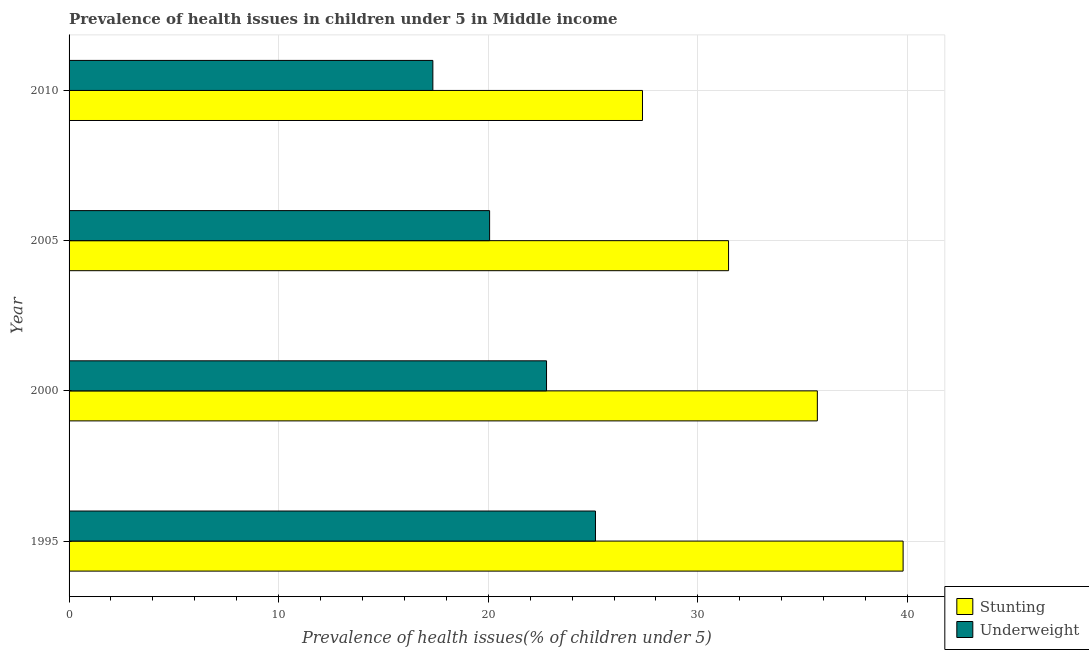How many different coloured bars are there?
Provide a succinct answer. 2. Are the number of bars on each tick of the Y-axis equal?
Your answer should be compact. Yes. What is the percentage of stunted children in 2005?
Your response must be concise. 31.46. Across all years, what is the maximum percentage of underweight children?
Ensure brevity in your answer.  25.11. Across all years, what is the minimum percentage of underweight children?
Provide a short and direct response. 17.36. In which year was the percentage of underweight children minimum?
Ensure brevity in your answer.  2010. What is the total percentage of stunted children in the graph?
Ensure brevity in your answer.  134.31. What is the difference between the percentage of underweight children in 2000 and that in 2005?
Ensure brevity in your answer.  2.72. What is the difference between the percentage of underweight children in 1995 and the percentage of stunted children in 2010?
Offer a very short reply. -2.24. What is the average percentage of stunted children per year?
Provide a succinct answer. 33.58. In the year 2010, what is the difference between the percentage of stunted children and percentage of underweight children?
Offer a terse response. 10. What is the ratio of the percentage of stunted children in 1995 to that in 2000?
Offer a very short reply. 1.11. Is the percentage of underweight children in 2005 less than that in 2010?
Provide a short and direct response. No. Is the difference between the percentage of stunted children in 1995 and 2005 greater than the difference between the percentage of underweight children in 1995 and 2005?
Keep it short and to the point. Yes. What is the difference between the highest and the second highest percentage of stunted children?
Your answer should be compact. 4.09. What is the difference between the highest and the lowest percentage of underweight children?
Your response must be concise. 7.76. Is the sum of the percentage of underweight children in 1995 and 2005 greater than the maximum percentage of stunted children across all years?
Provide a succinct answer. Yes. What does the 1st bar from the top in 1995 represents?
Provide a succinct answer. Underweight. What does the 1st bar from the bottom in 2000 represents?
Keep it short and to the point. Stunting. How many bars are there?
Provide a succinct answer. 8. Are all the bars in the graph horizontal?
Provide a short and direct response. Yes. How many years are there in the graph?
Provide a short and direct response. 4. What is the difference between two consecutive major ticks on the X-axis?
Your response must be concise. 10. Are the values on the major ticks of X-axis written in scientific E-notation?
Your answer should be very brief. No. Does the graph contain any zero values?
Make the answer very short. No. Does the graph contain grids?
Offer a very short reply. Yes. What is the title of the graph?
Offer a terse response. Prevalence of health issues in children under 5 in Middle income. What is the label or title of the X-axis?
Provide a short and direct response. Prevalence of health issues(% of children under 5). What is the Prevalence of health issues(% of children under 5) of Stunting in 1995?
Give a very brief answer. 39.79. What is the Prevalence of health issues(% of children under 5) of Underweight in 1995?
Keep it short and to the point. 25.11. What is the Prevalence of health issues(% of children under 5) in Stunting in 2000?
Your response must be concise. 35.7. What is the Prevalence of health issues(% of children under 5) of Underweight in 2000?
Your answer should be very brief. 22.78. What is the Prevalence of health issues(% of children under 5) in Stunting in 2005?
Make the answer very short. 31.46. What is the Prevalence of health issues(% of children under 5) of Underweight in 2005?
Provide a short and direct response. 20.06. What is the Prevalence of health issues(% of children under 5) in Stunting in 2010?
Give a very brief answer. 27.36. What is the Prevalence of health issues(% of children under 5) in Underweight in 2010?
Offer a terse response. 17.36. Across all years, what is the maximum Prevalence of health issues(% of children under 5) of Stunting?
Offer a very short reply. 39.79. Across all years, what is the maximum Prevalence of health issues(% of children under 5) in Underweight?
Ensure brevity in your answer.  25.11. Across all years, what is the minimum Prevalence of health issues(% of children under 5) of Stunting?
Keep it short and to the point. 27.36. Across all years, what is the minimum Prevalence of health issues(% of children under 5) of Underweight?
Provide a succinct answer. 17.36. What is the total Prevalence of health issues(% of children under 5) in Stunting in the graph?
Keep it short and to the point. 134.31. What is the total Prevalence of health issues(% of children under 5) in Underweight in the graph?
Make the answer very short. 85.31. What is the difference between the Prevalence of health issues(% of children under 5) of Stunting in 1995 and that in 2000?
Offer a very short reply. 4.09. What is the difference between the Prevalence of health issues(% of children under 5) in Underweight in 1995 and that in 2000?
Your answer should be compact. 2.33. What is the difference between the Prevalence of health issues(% of children under 5) in Stunting in 1995 and that in 2005?
Provide a short and direct response. 8.33. What is the difference between the Prevalence of health issues(% of children under 5) in Underweight in 1995 and that in 2005?
Your answer should be very brief. 5.05. What is the difference between the Prevalence of health issues(% of children under 5) in Stunting in 1995 and that in 2010?
Offer a very short reply. 12.43. What is the difference between the Prevalence of health issues(% of children under 5) in Underweight in 1995 and that in 2010?
Give a very brief answer. 7.76. What is the difference between the Prevalence of health issues(% of children under 5) of Stunting in 2000 and that in 2005?
Your answer should be very brief. 4.24. What is the difference between the Prevalence of health issues(% of children under 5) in Underweight in 2000 and that in 2005?
Offer a very short reply. 2.72. What is the difference between the Prevalence of health issues(% of children under 5) of Stunting in 2000 and that in 2010?
Your answer should be compact. 8.34. What is the difference between the Prevalence of health issues(% of children under 5) in Underweight in 2000 and that in 2010?
Your answer should be compact. 5.42. What is the difference between the Prevalence of health issues(% of children under 5) in Stunting in 2005 and that in 2010?
Ensure brevity in your answer.  4.11. What is the difference between the Prevalence of health issues(% of children under 5) in Underweight in 2005 and that in 2010?
Your answer should be very brief. 2.71. What is the difference between the Prevalence of health issues(% of children under 5) in Stunting in 1995 and the Prevalence of health issues(% of children under 5) in Underweight in 2000?
Make the answer very short. 17.01. What is the difference between the Prevalence of health issues(% of children under 5) of Stunting in 1995 and the Prevalence of health issues(% of children under 5) of Underweight in 2005?
Provide a succinct answer. 19.73. What is the difference between the Prevalence of health issues(% of children under 5) of Stunting in 1995 and the Prevalence of health issues(% of children under 5) of Underweight in 2010?
Provide a short and direct response. 22.44. What is the difference between the Prevalence of health issues(% of children under 5) in Stunting in 2000 and the Prevalence of health issues(% of children under 5) in Underweight in 2005?
Your response must be concise. 15.64. What is the difference between the Prevalence of health issues(% of children under 5) of Stunting in 2000 and the Prevalence of health issues(% of children under 5) of Underweight in 2010?
Provide a short and direct response. 18.34. What is the difference between the Prevalence of health issues(% of children under 5) in Stunting in 2005 and the Prevalence of health issues(% of children under 5) in Underweight in 2010?
Your answer should be very brief. 14.11. What is the average Prevalence of health issues(% of children under 5) of Stunting per year?
Make the answer very short. 33.58. What is the average Prevalence of health issues(% of children under 5) of Underweight per year?
Provide a short and direct response. 21.33. In the year 1995, what is the difference between the Prevalence of health issues(% of children under 5) in Stunting and Prevalence of health issues(% of children under 5) in Underweight?
Offer a terse response. 14.68. In the year 2000, what is the difference between the Prevalence of health issues(% of children under 5) of Stunting and Prevalence of health issues(% of children under 5) of Underweight?
Offer a terse response. 12.92. In the year 2005, what is the difference between the Prevalence of health issues(% of children under 5) in Stunting and Prevalence of health issues(% of children under 5) in Underweight?
Make the answer very short. 11.4. In the year 2010, what is the difference between the Prevalence of health issues(% of children under 5) in Stunting and Prevalence of health issues(% of children under 5) in Underweight?
Your response must be concise. 10. What is the ratio of the Prevalence of health issues(% of children under 5) of Stunting in 1995 to that in 2000?
Your answer should be compact. 1.11. What is the ratio of the Prevalence of health issues(% of children under 5) in Underweight in 1995 to that in 2000?
Make the answer very short. 1.1. What is the ratio of the Prevalence of health issues(% of children under 5) of Stunting in 1995 to that in 2005?
Offer a terse response. 1.26. What is the ratio of the Prevalence of health issues(% of children under 5) of Underweight in 1995 to that in 2005?
Keep it short and to the point. 1.25. What is the ratio of the Prevalence of health issues(% of children under 5) in Stunting in 1995 to that in 2010?
Provide a short and direct response. 1.45. What is the ratio of the Prevalence of health issues(% of children under 5) of Underweight in 1995 to that in 2010?
Provide a succinct answer. 1.45. What is the ratio of the Prevalence of health issues(% of children under 5) in Stunting in 2000 to that in 2005?
Your answer should be compact. 1.13. What is the ratio of the Prevalence of health issues(% of children under 5) of Underweight in 2000 to that in 2005?
Your answer should be compact. 1.14. What is the ratio of the Prevalence of health issues(% of children under 5) of Stunting in 2000 to that in 2010?
Provide a short and direct response. 1.3. What is the ratio of the Prevalence of health issues(% of children under 5) of Underweight in 2000 to that in 2010?
Your response must be concise. 1.31. What is the ratio of the Prevalence of health issues(% of children under 5) of Stunting in 2005 to that in 2010?
Provide a succinct answer. 1.15. What is the ratio of the Prevalence of health issues(% of children under 5) of Underweight in 2005 to that in 2010?
Provide a succinct answer. 1.16. What is the difference between the highest and the second highest Prevalence of health issues(% of children under 5) in Stunting?
Make the answer very short. 4.09. What is the difference between the highest and the second highest Prevalence of health issues(% of children under 5) of Underweight?
Your response must be concise. 2.33. What is the difference between the highest and the lowest Prevalence of health issues(% of children under 5) in Stunting?
Ensure brevity in your answer.  12.43. What is the difference between the highest and the lowest Prevalence of health issues(% of children under 5) in Underweight?
Offer a terse response. 7.76. 